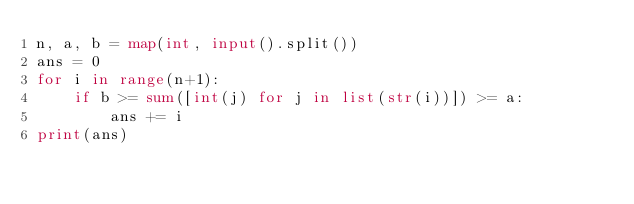<code> <loc_0><loc_0><loc_500><loc_500><_Python_>n, a, b = map(int, input().split())
ans = 0
for i in range(n+1):
    if b >= sum([int(j) for j in list(str(i))]) >= a:
        ans += i
print(ans)
</code> 